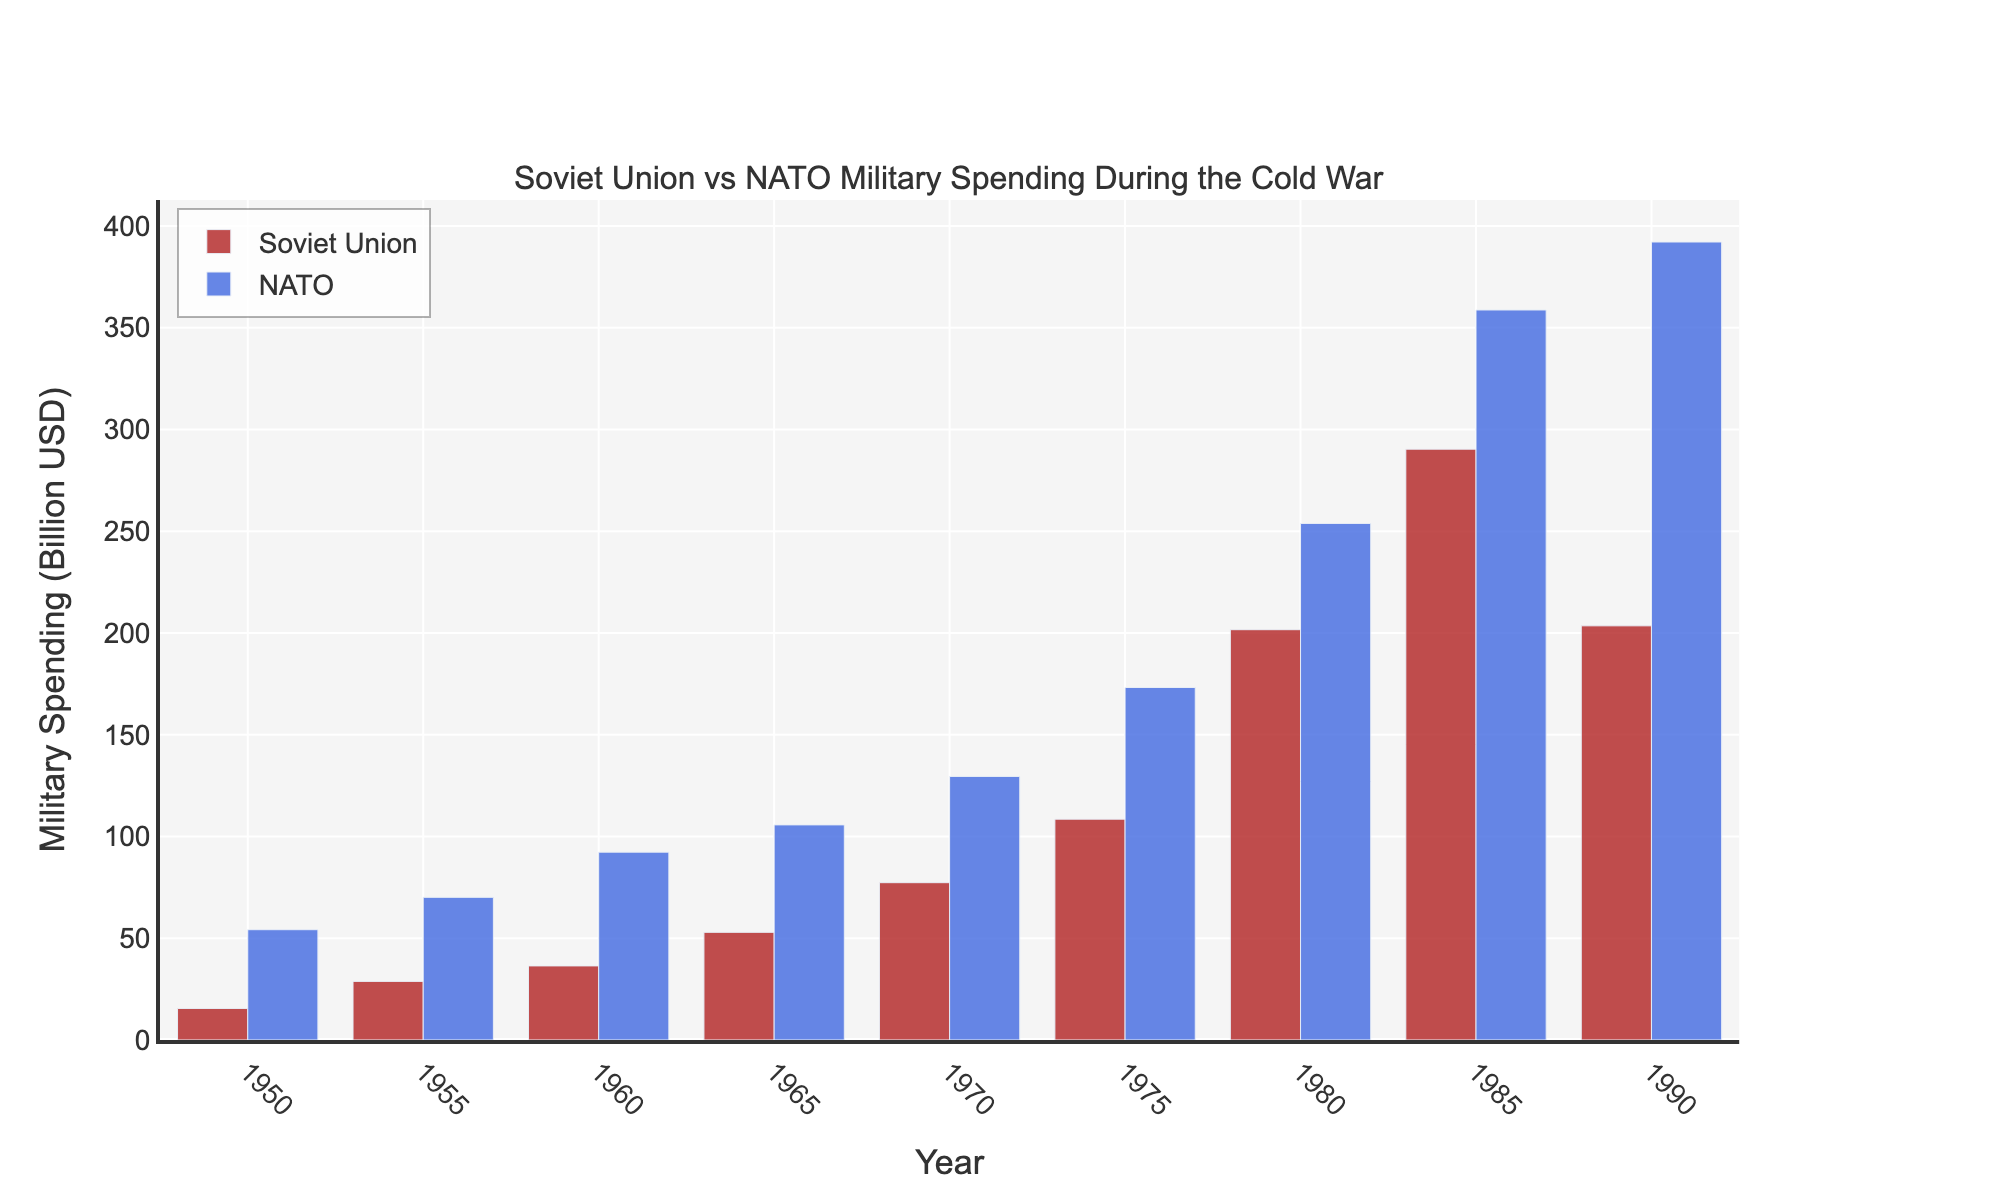What is the difference in military spending between NATO and the Soviet Union in 1990? In 1990, NATO's spending was 392.1 billion USD and the Soviet Union's spending was 203.5 billion USD. The difference is 392.1 - 203.5 = 188.6 billion USD.
Answer: 188.6 billion USD Which year shows the smallest difference in military spending between NATO and the Soviet Union? Comparing the differences for each year: 1950 (38.7), 1955 (41.3), 1960 (55.9), 1965 (52.8), 1970 (52.2), 1975 (64.7), 1980 (52.2), 1985 (68.4), 1990 (188.6), the smallest difference is in 1950 with 38.7 billion USD.
Answer: 1950 How much did the Soviet Union's military spending increase from 1950 to 1985? The Soviet Union's spending in 1950 was 15.5 billion USD and in 1985 it was 290.3 billion USD. The increase is 290.3 - 15.5 = 274.8 billion USD.
Answer: 274.8 billion USD In which year did NATO's military spending see the largest increase compared to the previous recorded year? Examining the changes: 1955 (15.9), 1960 (22.2), 1965 (13.4), 1970 (23.8), 1975 (43.7), 1980 (80.6), 1985 (104.9), 1990 (33.4), the largest increase was between 1980 and 1985, with an increase of 104.9 billion USD.
Answer: Between 1980 and 1985 What is the total military spending of both NATO and the Soviet Union in 1970? Adding NATO's and the Soviet Union's military spending in 1970: 129.5 + 77.3 = 206.8 billion USD.
Answer: 206.8 billion USD Which year had the highest military spending for the Soviet Union? The Soviet Union had the highest military spending in 1985 with 290.3 billion USD.
Answer: 1985 How does the height of the 1980 bar for the Soviet Union compare to the 1980 bar for NATO? Visually comparing the heights, NATO's 1980 bar is significantly taller than the Soviet Union's 1980 bar, indicating higher spending.
Answer: NATO's bar is taller What is the average military spending for NATO across all the years shown? Summing NATO's spending: 54.2 + 70.1 + 92.3 + 105.7 + 129.5 + 173.2 + 253.8 + 358.7 + 392.1, total = 1629.6. There are 9 years, so the average is 1629.6 / 9 = 181.07 billion USD.
Answer: 181.07 billion USD 